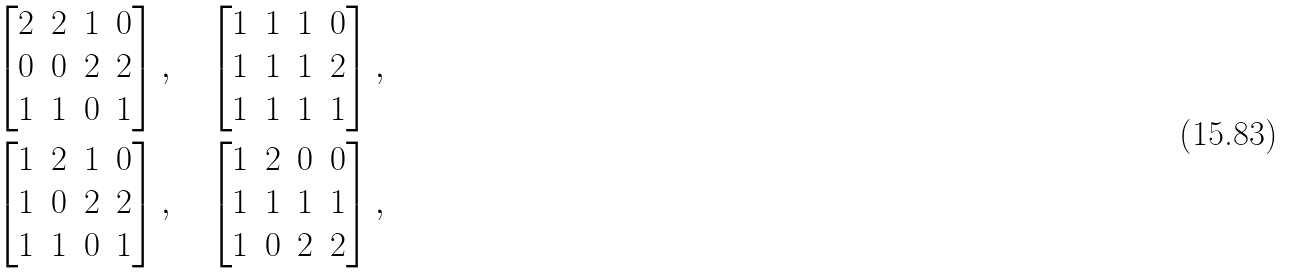<formula> <loc_0><loc_0><loc_500><loc_500>& \begin{bmatrix} 2 & 2 & 1 & 0 \\ 0 & 0 & 2 & 2 \\ 1 & 1 & 0 & 1 \end{bmatrix} , \quad \begin{bmatrix} 1 & 1 & 1 & 0 \\ 1 & 1 & 1 & 2 \\ 1 & 1 & 1 & 1 \end{bmatrix} , \\ & \begin{bmatrix} 1 & 2 & 1 & 0 \\ 1 & 0 & 2 & 2 \\ 1 & 1 & 0 & 1 \end{bmatrix} , \quad \begin{bmatrix} 1 & 2 & 0 & 0 \\ 1 & 1 & 1 & 1 \\ 1 & 0 & 2 & 2 \end{bmatrix} ,</formula> 